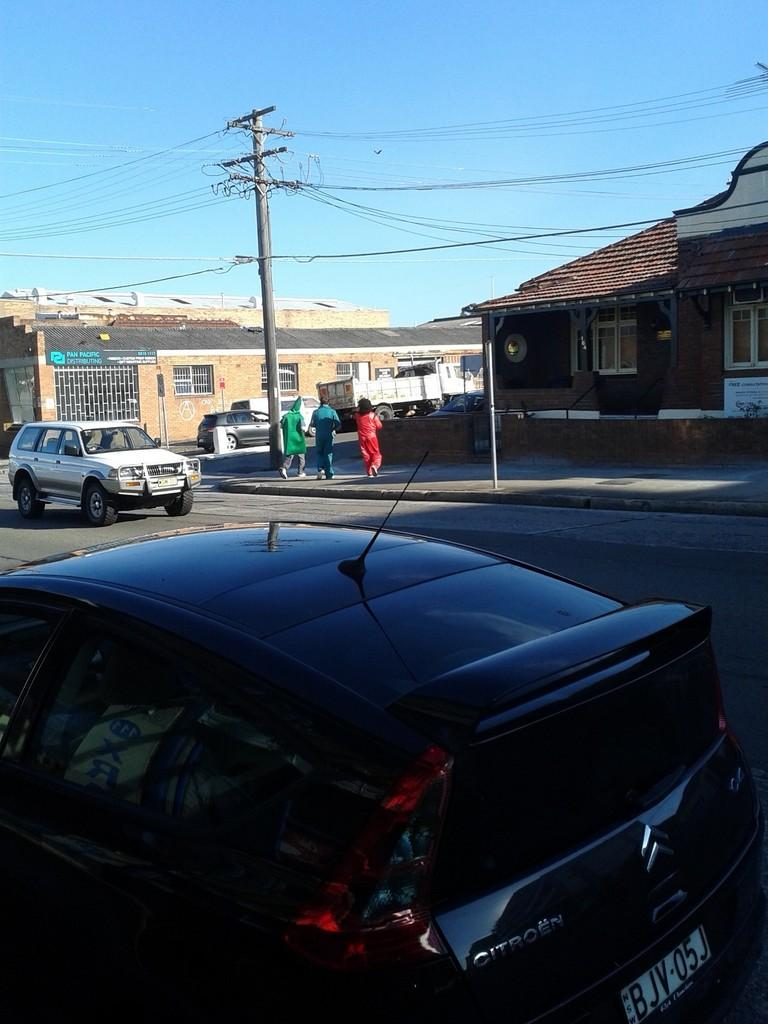What is happening on the road in the image? There are vehicles on the road in the image, and people are crossing the road. What is located near the road in the image? There is a current pole in the image. What can be seen in the background of the image? There are buildings and the sky visible in the background of the image. What type of bone can be seen in the image? There is no bone present in the image. How many people are in the crowd crossing the road in the image? There is no crowd in the image; only a few people are crossing the road. 